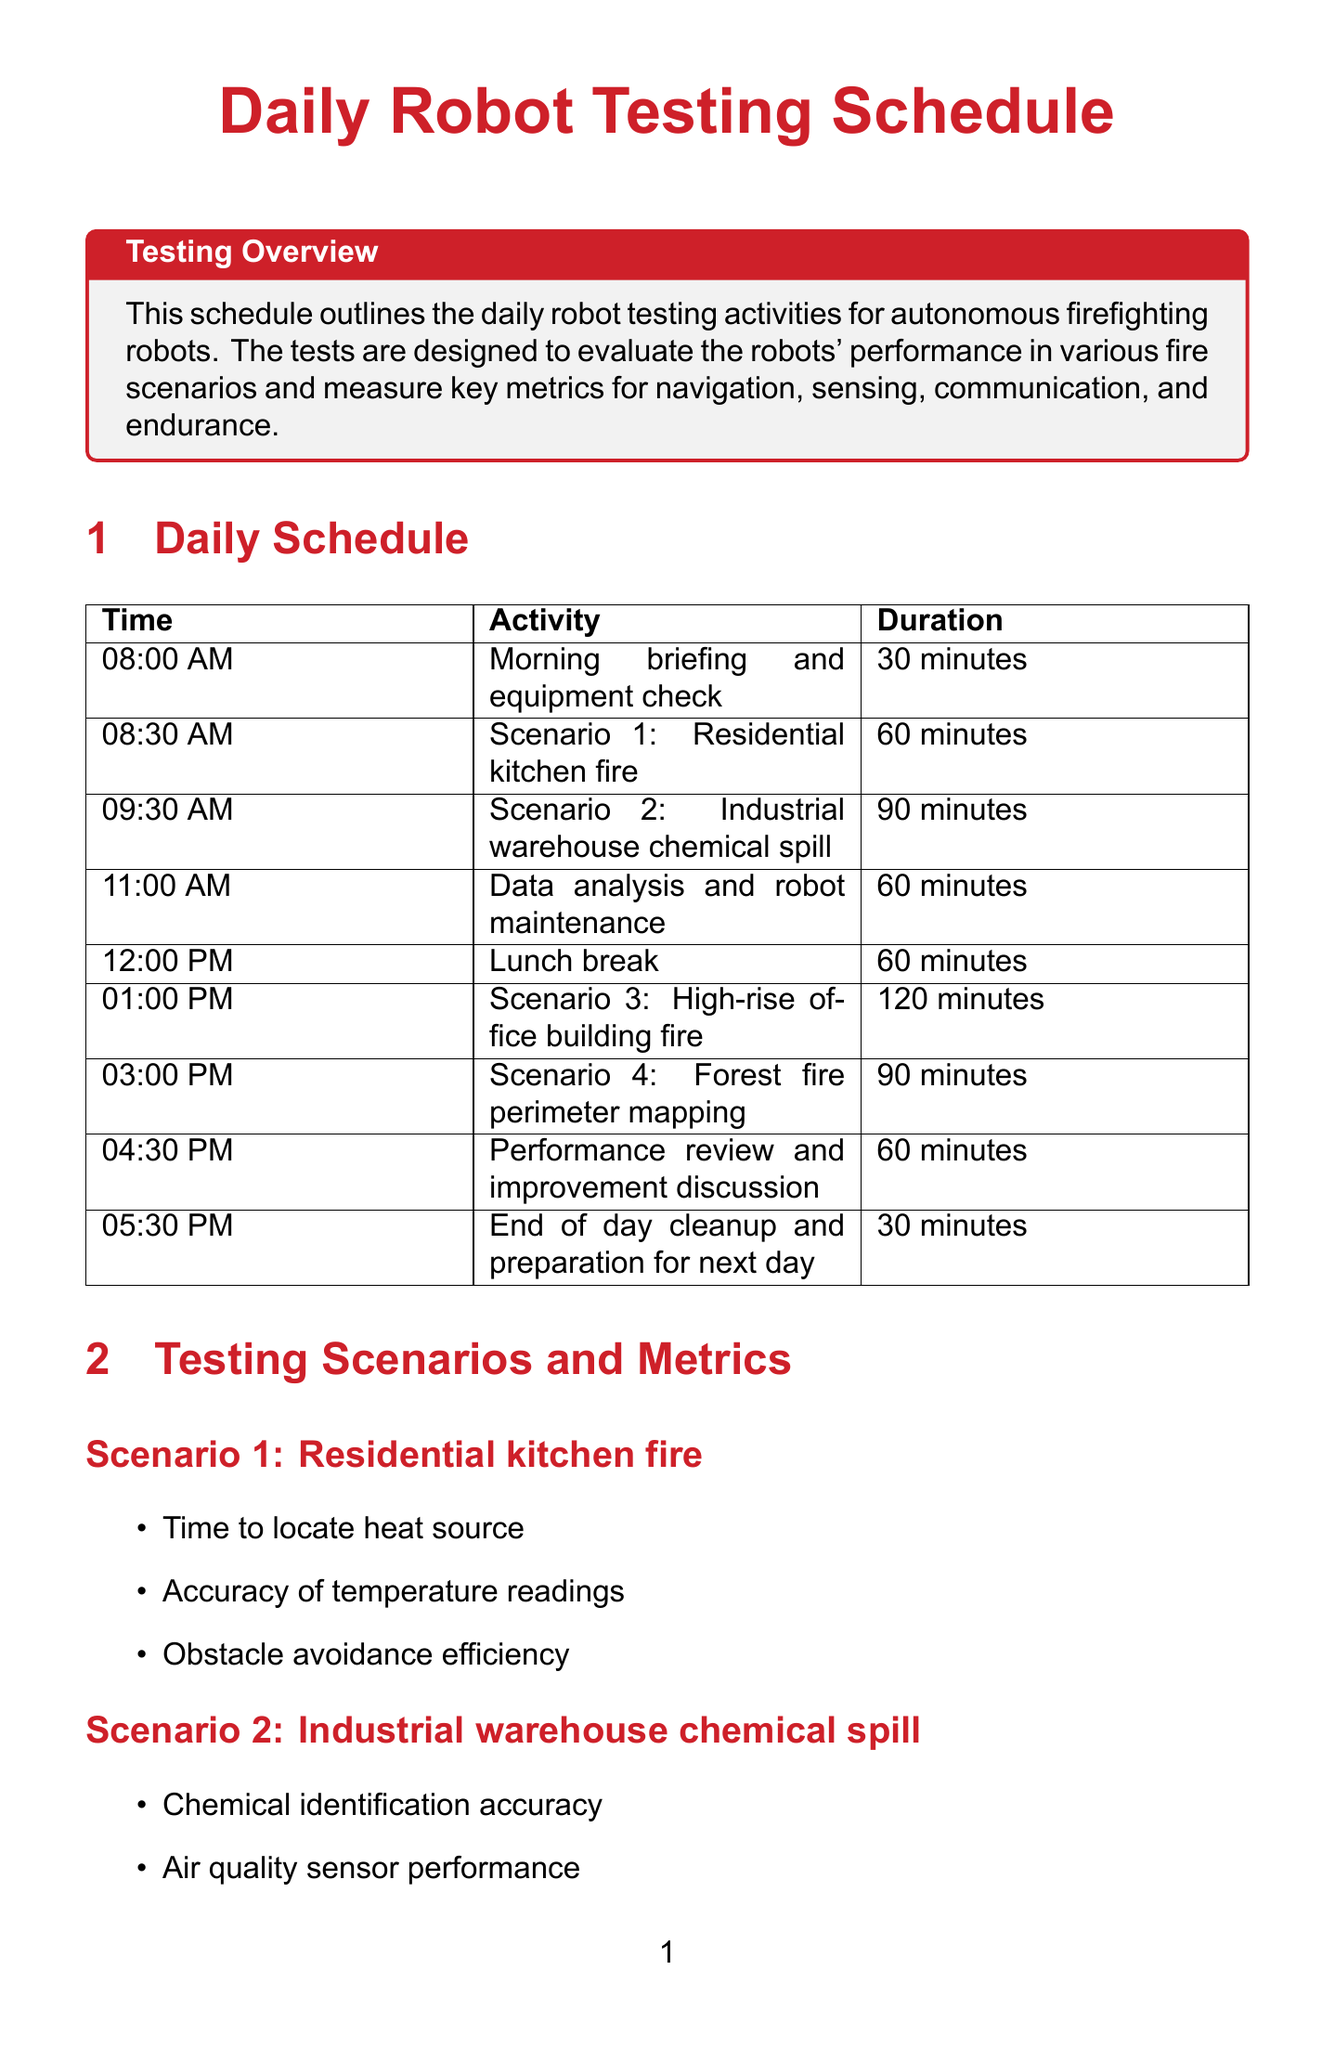what time does the morning briefing start? The morning briefing starts at 08:00 AM as listed in the schedule.
Answer: 08:00 AM how long is the scenario for the high-rise office building fire? The duration for the high-rise office building fire scenario is 120 minutes according to the schedule.
Answer: 120 minutes which robot is manufactured by Howe and Howe Technologies? The robot manufactured by Howe and Howe Technologies is the Thermite RS3, as specified in the document.
Answer: Thermite RS3 what metric is assessed during the forest fire perimeter mapping? One of the metrics assessed during the forest fire perimeter mapping is GPS accuracy in dense foliage.
Answer: GPS accuracy in dense foliage how many minutes is allocated for lunch break? The lunch break is allocated 60 minutes as mentioned in the schedule.
Answer: 60 minutes which testing location features a simulated subway station? The FDNY Training Academy features a simulated subway station as noted in the document.
Answer: FDNY Training Academy what is the last activity scheduled for the day? The last activity scheduled for the day is the end of day cleanup and preparation for next day.
Answer: End of day cleanup and preparation for next day how many distinct performance metrics are listed for the industrial warehouse chemical spill? There are three distinct performance metrics listed for the industrial warehouse chemical spill.
Answer: Three what is the duration of the data analysis and robot maintenance period? The duration for data analysis and robot maintenance is 60 minutes according to the schedule.
Answer: 60 minutes 